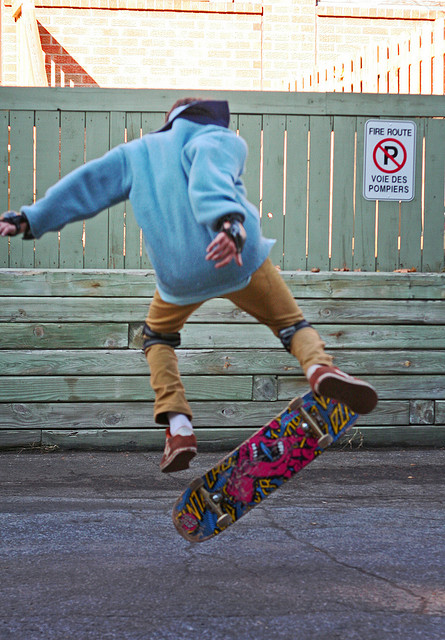Read all the text in this image. FIRE ROUTE P VOIE POMPIERS DES 